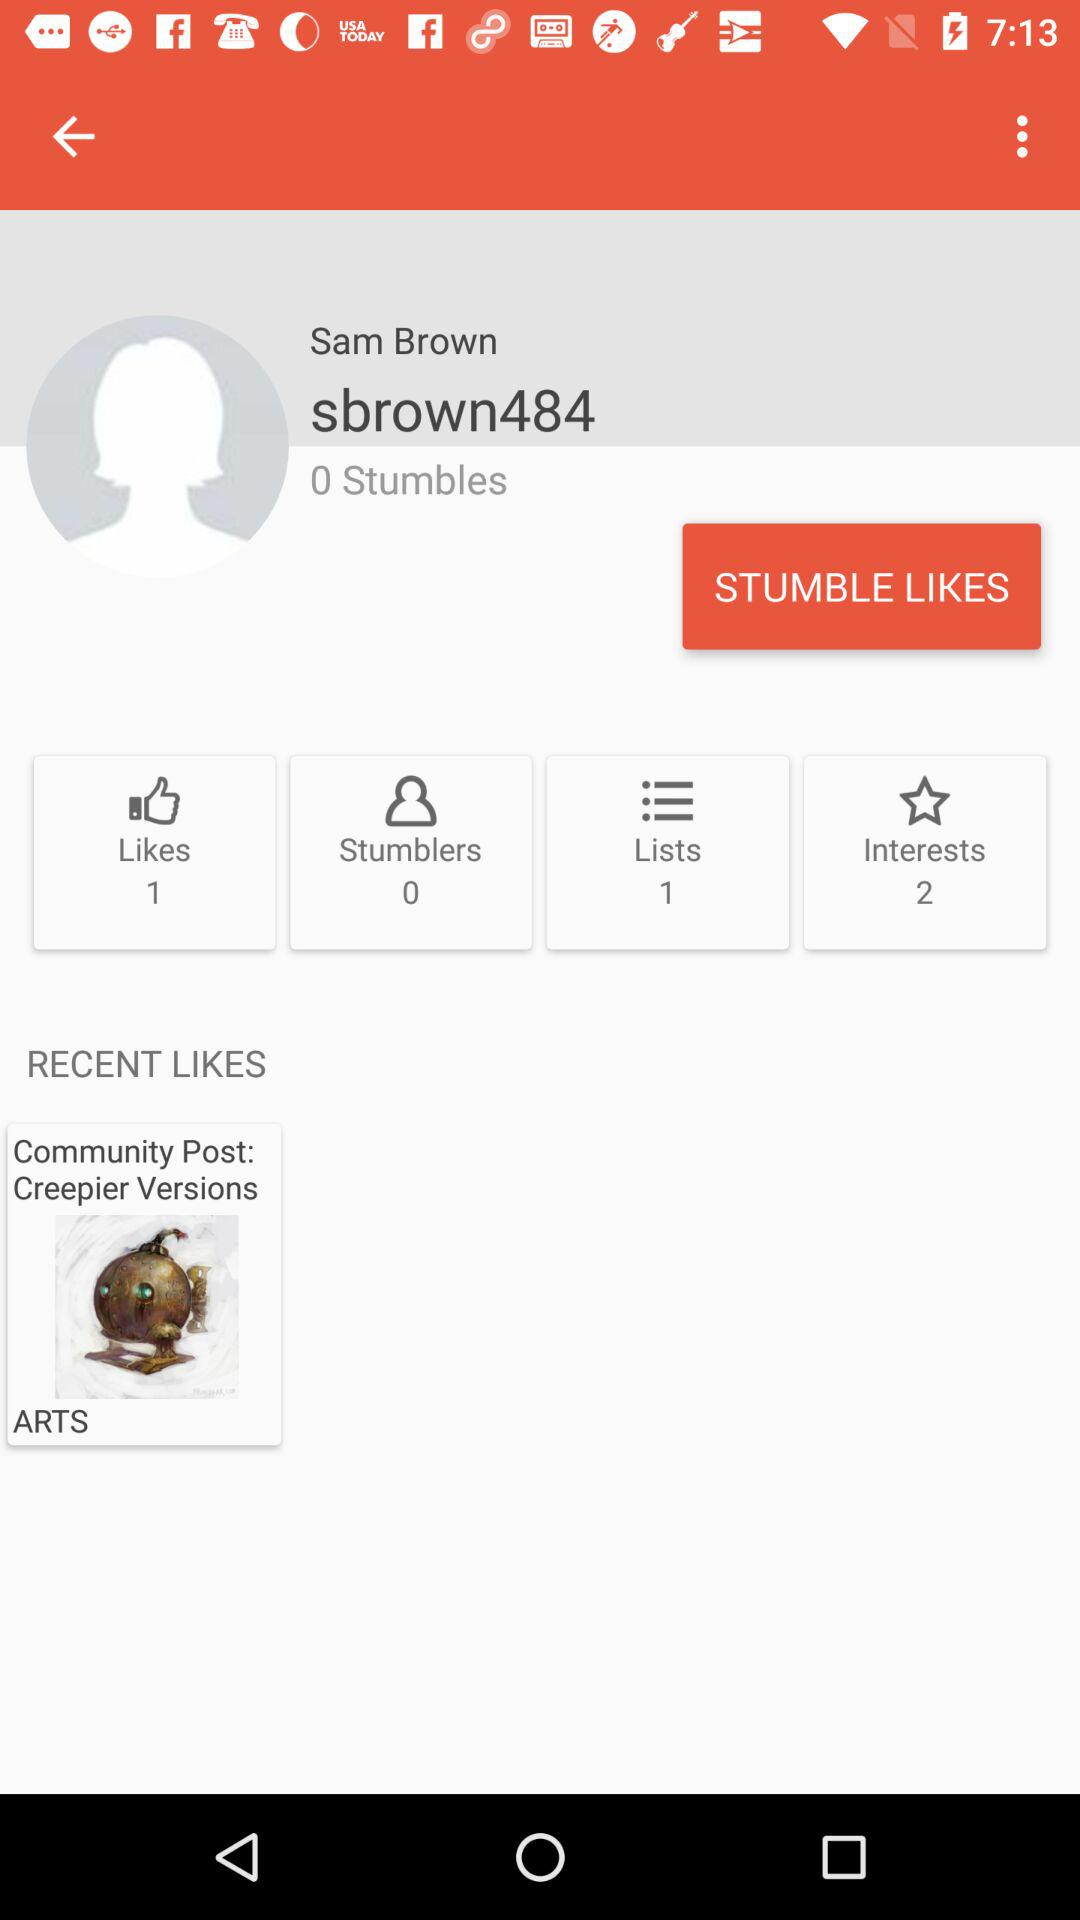What is Sam Brown's ID? Sam Brown's ID is "sbrown484". 